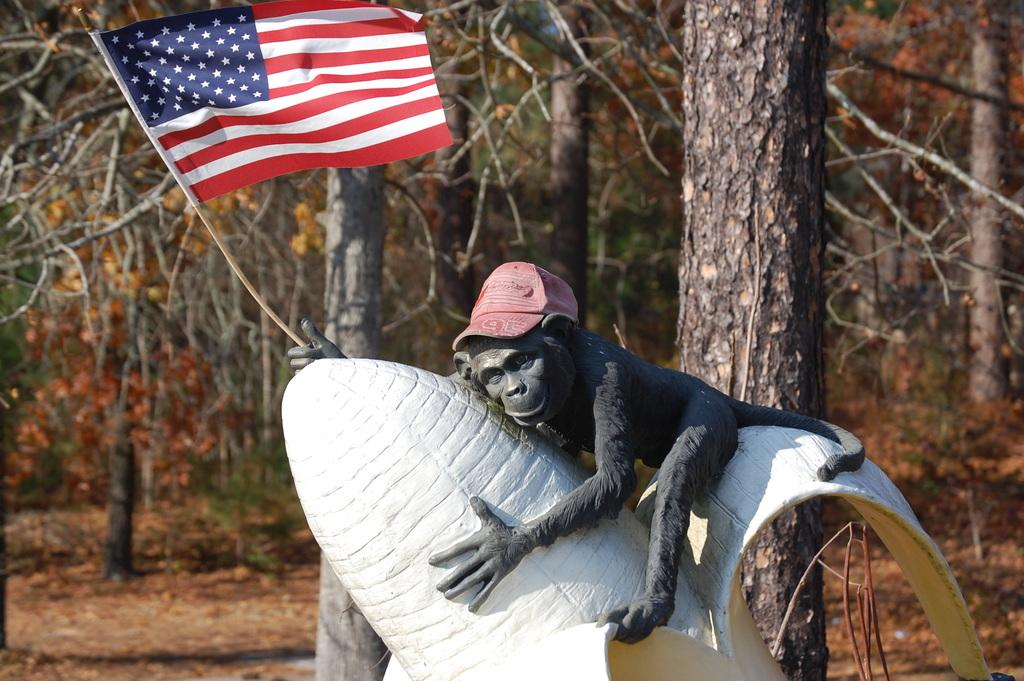What is the main subject in the foreground of the image? There is a sculpture in the foreground of the image. What is the sculpture depicting? The sculpture features a monkey holding a flag. What is the monkey wearing? The monkey is wearing a cap. What can be seen in the background of the image? There are trees in the background of the image. Are there any fairies visible in the image? No, there are no fairies present in the image. What type of drug can be seen in the monkey's hand in the image? There is no drug present in the image; the monkey is holding a flag. 